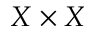Convert formula to latex. <formula><loc_0><loc_0><loc_500><loc_500>X \times X</formula> 